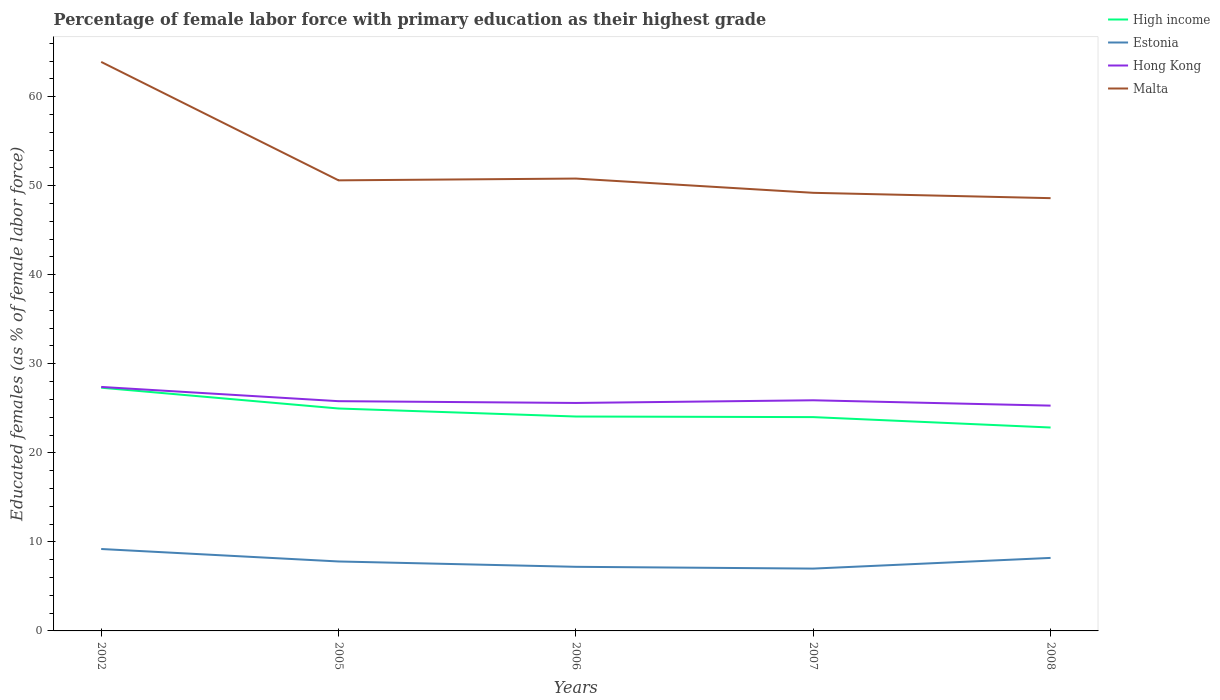Across all years, what is the maximum percentage of female labor force with primary education in Malta?
Your response must be concise. 48.6. What is the total percentage of female labor force with primary education in High income in the graph?
Your response must be concise. 1.24. What is the difference between the highest and the second highest percentage of female labor force with primary education in High income?
Ensure brevity in your answer.  4.47. What is the difference between the highest and the lowest percentage of female labor force with primary education in Malta?
Offer a very short reply. 1. How many lines are there?
Offer a very short reply. 4. How many years are there in the graph?
Your answer should be very brief. 5. What is the difference between two consecutive major ticks on the Y-axis?
Give a very brief answer. 10. Are the values on the major ticks of Y-axis written in scientific E-notation?
Give a very brief answer. No. Does the graph contain grids?
Provide a short and direct response. No. How are the legend labels stacked?
Make the answer very short. Vertical. What is the title of the graph?
Make the answer very short. Percentage of female labor force with primary education as their highest grade. Does "Channel Islands" appear as one of the legend labels in the graph?
Keep it short and to the point. No. What is the label or title of the X-axis?
Your answer should be compact. Years. What is the label or title of the Y-axis?
Your answer should be very brief. Educated females (as % of female labor force). What is the Educated females (as % of female labor force) in High income in 2002?
Offer a very short reply. 27.32. What is the Educated females (as % of female labor force) in Estonia in 2002?
Your response must be concise. 9.2. What is the Educated females (as % of female labor force) of Hong Kong in 2002?
Provide a succinct answer. 27.4. What is the Educated females (as % of female labor force) of Malta in 2002?
Make the answer very short. 63.9. What is the Educated females (as % of female labor force) in High income in 2005?
Give a very brief answer. 24.98. What is the Educated females (as % of female labor force) in Estonia in 2005?
Keep it short and to the point. 7.8. What is the Educated females (as % of female labor force) in Hong Kong in 2005?
Keep it short and to the point. 25.8. What is the Educated females (as % of female labor force) of Malta in 2005?
Offer a terse response. 50.6. What is the Educated females (as % of female labor force) of High income in 2006?
Your answer should be very brief. 24.08. What is the Educated females (as % of female labor force) of Estonia in 2006?
Offer a very short reply. 7.2. What is the Educated females (as % of female labor force) in Hong Kong in 2006?
Make the answer very short. 25.6. What is the Educated females (as % of female labor force) of Malta in 2006?
Offer a very short reply. 50.8. What is the Educated females (as % of female labor force) of High income in 2007?
Your answer should be compact. 24.01. What is the Educated females (as % of female labor force) in Hong Kong in 2007?
Keep it short and to the point. 25.9. What is the Educated females (as % of female labor force) of Malta in 2007?
Your answer should be very brief. 49.2. What is the Educated females (as % of female labor force) in High income in 2008?
Your answer should be very brief. 22.84. What is the Educated females (as % of female labor force) in Estonia in 2008?
Your answer should be compact. 8.2. What is the Educated females (as % of female labor force) of Hong Kong in 2008?
Offer a very short reply. 25.3. What is the Educated females (as % of female labor force) in Malta in 2008?
Your answer should be compact. 48.6. Across all years, what is the maximum Educated females (as % of female labor force) in High income?
Provide a short and direct response. 27.32. Across all years, what is the maximum Educated females (as % of female labor force) in Estonia?
Give a very brief answer. 9.2. Across all years, what is the maximum Educated females (as % of female labor force) in Hong Kong?
Your answer should be very brief. 27.4. Across all years, what is the maximum Educated females (as % of female labor force) in Malta?
Your answer should be compact. 63.9. Across all years, what is the minimum Educated females (as % of female labor force) of High income?
Ensure brevity in your answer.  22.84. Across all years, what is the minimum Educated females (as % of female labor force) in Estonia?
Provide a succinct answer. 7. Across all years, what is the minimum Educated females (as % of female labor force) of Hong Kong?
Keep it short and to the point. 25.3. Across all years, what is the minimum Educated females (as % of female labor force) in Malta?
Your response must be concise. 48.6. What is the total Educated females (as % of female labor force) of High income in the graph?
Keep it short and to the point. 123.22. What is the total Educated females (as % of female labor force) of Estonia in the graph?
Your response must be concise. 39.4. What is the total Educated females (as % of female labor force) in Hong Kong in the graph?
Give a very brief answer. 130. What is the total Educated females (as % of female labor force) of Malta in the graph?
Keep it short and to the point. 263.1. What is the difference between the Educated females (as % of female labor force) in High income in 2002 and that in 2005?
Offer a terse response. 2.34. What is the difference between the Educated females (as % of female labor force) of Estonia in 2002 and that in 2005?
Your response must be concise. 1.4. What is the difference between the Educated females (as % of female labor force) of Hong Kong in 2002 and that in 2005?
Make the answer very short. 1.6. What is the difference between the Educated females (as % of female labor force) of Malta in 2002 and that in 2005?
Keep it short and to the point. 13.3. What is the difference between the Educated females (as % of female labor force) in High income in 2002 and that in 2006?
Provide a short and direct response. 3.24. What is the difference between the Educated females (as % of female labor force) of Estonia in 2002 and that in 2006?
Your answer should be very brief. 2. What is the difference between the Educated females (as % of female labor force) of High income in 2002 and that in 2007?
Your answer should be compact. 3.3. What is the difference between the Educated females (as % of female labor force) of Estonia in 2002 and that in 2007?
Make the answer very short. 2.2. What is the difference between the Educated females (as % of female labor force) of Hong Kong in 2002 and that in 2007?
Your answer should be very brief. 1.5. What is the difference between the Educated females (as % of female labor force) in High income in 2002 and that in 2008?
Your answer should be compact. 4.47. What is the difference between the Educated females (as % of female labor force) of High income in 2005 and that in 2006?
Your answer should be very brief. 0.9. What is the difference between the Educated females (as % of female labor force) in Estonia in 2005 and that in 2006?
Provide a short and direct response. 0.6. What is the difference between the Educated females (as % of female labor force) in High income in 2005 and that in 2007?
Make the answer very short. 0.97. What is the difference between the Educated females (as % of female labor force) in Estonia in 2005 and that in 2007?
Your answer should be compact. 0.8. What is the difference between the Educated females (as % of female labor force) in Hong Kong in 2005 and that in 2007?
Your answer should be very brief. -0.1. What is the difference between the Educated females (as % of female labor force) in High income in 2005 and that in 2008?
Your answer should be very brief. 2.14. What is the difference between the Educated females (as % of female labor force) of Estonia in 2005 and that in 2008?
Give a very brief answer. -0.4. What is the difference between the Educated females (as % of female labor force) in Hong Kong in 2005 and that in 2008?
Give a very brief answer. 0.5. What is the difference between the Educated females (as % of female labor force) of High income in 2006 and that in 2007?
Make the answer very short. 0.07. What is the difference between the Educated females (as % of female labor force) in Estonia in 2006 and that in 2007?
Keep it short and to the point. 0.2. What is the difference between the Educated females (as % of female labor force) in Hong Kong in 2006 and that in 2007?
Keep it short and to the point. -0.3. What is the difference between the Educated females (as % of female labor force) in Malta in 2006 and that in 2007?
Make the answer very short. 1.6. What is the difference between the Educated females (as % of female labor force) of High income in 2006 and that in 2008?
Keep it short and to the point. 1.24. What is the difference between the Educated females (as % of female labor force) in Hong Kong in 2006 and that in 2008?
Ensure brevity in your answer.  0.3. What is the difference between the Educated females (as % of female labor force) in High income in 2007 and that in 2008?
Your response must be concise. 1.17. What is the difference between the Educated females (as % of female labor force) of Malta in 2007 and that in 2008?
Make the answer very short. 0.6. What is the difference between the Educated females (as % of female labor force) in High income in 2002 and the Educated females (as % of female labor force) in Estonia in 2005?
Make the answer very short. 19.52. What is the difference between the Educated females (as % of female labor force) of High income in 2002 and the Educated females (as % of female labor force) of Hong Kong in 2005?
Make the answer very short. 1.51. What is the difference between the Educated females (as % of female labor force) of High income in 2002 and the Educated females (as % of female labor force) of Malta in 2005?
Give a very brief answer. -23.29. What is the difference between the Educated females (as % of female labor force) of Estonia in 2002 and the Educated females (as % of female labor force) of Hong Kong in 2005?
Your response must be concise. -16.6. What is the difference between the Educated females (as % of female labor force) in Estonia in 2002 and the Educated females (as % of female labor force) in Malta in 2005?
Provide a short and direct response. -41.4. What is the difference between the Educated females (as % of female labor force) of Hong Kong in 2002 and the Educated females (as % of female labor force) of Malta in 2005?
Give a very brief answer. -23.2. What is the difference between the Educated females (as % of female labor force) of High income in 2002 and the Educated females (as % of female labor force) of Estonia in 2006?
Provide a succinct answer. 20.11. What is the difference between the Educated females (as % of female labor force) of High income in 2002 and the Educated females (as % of female labor force) of Hong Kong in 2006?
Provide a short and direct response. 1.72. What is the difference between the Educated females (as % of female labor force) in High income in 2002 and the Educated females (as % of female labor force) in Malta in 2006?
Make the answer very short. -23.48. What is the difference between the Educated females (as % of female labor force) in Estonia in 2002 and the Educated females (as % of female labor force) in Hong Kong in 2006?
Provide a succinct answer. -16.4. What is the difference between the Educated females (as % of female labor force) in Estonia in 2002 and the Educated females (as % of female labor force) in Malta in 2006?
Provide a succinct answer. -41.6. What is the difference between the Educated females (as % of female labor force) of Hong Kong in 2002 and the Educated females (as % of female labor force) of Malta in 2006?
Provide a short and direct response. -23.4. What is the difference between the Educated females (as % of female labor force) in High income in 2002 and the Educated females (as % of female labor force) in Estonia in 2007?
Provide a succinct answer. 20.32. What is the difference between the Educated females (as % of female labor force) in High income in 2002 and the Educated females (as % of female labor force) in Hong Kong in 2007?
Your answer should be very brief. 1.42. What is the difference between the Educated females (as % of female labor force) in High income in 2002 and the Educated females (as % of female labor force) in Malta in 2007?
Your answer should be very brief. -21.89. What is the difference between the Educated females (as % of female labor force) in Estonia in 2002 and the Educated females (as % of female labor force) in Hong Kong in 2007?
Provide a succinct answer. -16.7. What is the difference between the Educated females (as % of female labor force) in Estonia in 2002 and the Educated females (as % of female labor force) in Malta in 2007?
Ensure brevity in your answer.  -40. What is the difference between the Educated females (as % of female labor force) in Hong Kong in 2002 and the Educated females (as % of female labor force) in Malta in 2007?
Ensure brevity in your answer.  -21.8. What is the difference between the Educated females (as % of female labor force) in High income in 2002 and the Educated females (as % of female labor force) in Estonia in 2008?
Your answer should be compact. 19.11. What is the difference between the Educated females (as % of female labor force) of High income in 2002 and the Educated females (as % of female labor force) of Hong Kong in 2008?
Keep it short and to the point. 2.02. What is the difference between the Educated females (as % of female labor force) in High income in 2002 and the Educated females (as % of female labor force) in Malta in 2008?
Offer a terse response. -21.29. What is the difference between the Educated females (as % of female labor force) in Estonia in 2002 and the Educated females (as % of female labor force) in Hong Kong in 2008?
Provide a short and direct response. -16.1. What is the difference between the Educated females (as % of female labor force) of Estonia in 2002 and the Educated females (as % of female labor force) of Malta in 2008?
Offer a very short reply. -39.4. What is the difference between the Educated females (as % of female labor force) in Hong Kong in 2002 and the Educated females (as % of female labor force) in Malta in 2008?
Your answer should be very brief. -21.2. What is the difference between the Educated females (as % of female labor force) of High income in 2005 and the Educated females (as % of female labor force) of Estonia in 2006?
Give a very brief answer. 17.78. What is the difference between the Educated females (as % of female labor force) of High income in 2005 and the Educated females (as % of female labor force) of Hong Kong in 2006?
Give a very brief answer. -0.62. What is the difference between the Educated females (as % of female labor force) in High income in 2005 and the Educated females (as % of female labor force) in Malta in 2006?
Keep it short and to the point. -25.82. What is the difference between the Educated females (as % of female labor force) in Estonia in 2005 and the Educated females (as % of female labor force) in Hong Kong in 2006?
Your answer should be compact. -17.8. What is the difference between the Educated females (as % of female labor force) of Estonia in 2005 and the Educated females (as % of female labor force) of Malta in 2006?
Your response must be concise. -43. What is the difference between the Educated females (as % of female labor force) of High income in 2005 and the Educated females (as % of female labor force) of Estonia in 2007?
Keep it short and to the point. 17.98. What is the difference between the Educated females (as % of female labor force) of High income in 2005 and the Educated females (as % of female labor force) of Hong Kong in 2007?
Your response must be concise. -0.92. What is the difference between the Educated females (as % of female labor force) of High income in 2005 and the Educated females (as % of female labor force) of Malta in 2007?
Offer a very short reply. -24.22. What is the difference between the Educated females (as % of female labor force) of Estonia in 2005 and the Educated females (as % of female labor force) of Hong Kong in 2007?
Make the answer very short. -18.1. What is the difference between the Educated females (as % of female labor force) in Estonia in 2005 and the Educated females (as % of female labor force) in Malta in 2007?
Ensure brevity in your answer.  -41.4. What is the difference between the Educated females (as % of female labor force) of Hong Kong in 2005 and the Educated females (as % of female labor force) of Malta in 2007?
Provide a short and direct response. -23.4. What is the difference between the Educated females (as % of female labor force) of High income in 2005 and the Educated females (as % of female labor force) of Estonia in 2008?
Make the answer very short. 16.78. What is the difference between the Educated females (as % of female labor force) of High income in 2005 and the Educated females (as % of female labor force) of Hong Kong in 2008?
Offer a very short reply. -0.32. What is the difference between the Educated females (as % of female labor force) of High income in 2005 and the Educated females (as % of female labor force) of Malta in 2008?
Your response must be concise. -23.62. What is the difference between the Educated females (as % of female labor force) of Estonia in 2005 and the Educated females (as % of female labor force) of Hong Kong in 2008?
Offer a terse response. -17.5. What is the difference between the Educated females (as % of female labor force) of Estonia in 2005 and the Educated females (as % of female labor force) of Malta in 2008?
Keep it short and to the point. -40.8. What is the difference between the Educated females (as % of female labor force) of Hong Kong in 2005 and the Educated females (as % of female labor force) of Malta in 2008?
Keep it short and to the point. -22.8. What is the difference between the Educated females (as % of female labor force) in High income in 2006 and the Educated females (as % of female labor force) in Estonia in 2007?
Give a very brief answer. 17.08. What is the difference between the Educated females (as % of female labor force) in High income in 2006 and the Educated females (as % of female labor force) in Hong Kong in 2007?
Offer a very short reply. -1.82. What is the difference between the Educated females (as % of female labor force) in High income in 2006 and the Educated females (as % of female labor force) in Malta in 2007?
Ensure brevity in your answer.  -25.12. What is the difference between the Educated females (as % of female labor force) in Estonia in 2006 and the Educated females (as % of female labor force) in Hong Kong in 2007?
Provide a succinct answer. -18.7. What is the difference between the Educated females (as % of female labor force) in Estonia in 2006 and the Educated females (as % of female labor force) in Malta in 2007?
Provide a succinct answer. -42. What is the difference between the Educated females (as % of female labor force) in Hong Kong in 2006 and the Educated females (as % of female labor force) in Malta in 2007?
Your answer should be compact. -23.6. What is the difference between the Educated females (as % of female labor force) of High income in 2006 and the Educated females (as % of female labor force) of Estonia in 2008?
Ensure brevity in your answer.  15.88. What is the difference between the Educated females (as % of female labor force) of High income in 2006 and the Educated females (as % of female labor force) of Hong Kong in 2008?
Provide a succinct answer. -1.22. What is the difference between the Educated females (as % of female labor force) in High income in 2006 and the Educated females (as % of female labor force) in Malta in 2008?
Ensure brevity in your answer.  -24.52. What is the difference between the Educated females (as % of female labor force) of Estonia in 2006 and the Educated females (as % of female labor force) of Hong Kong in 2008?
Give a very brief answer. -18.1. What is the difference between the Educated females (as % of female labor force) of Estonia in 2006 and the Educated females (as % of female labor force) of Malta in 2008?
Make the answer very short. -41.4. What is the difference between the Educated females (as % of female labor force) in High income in 2007 and the Educated females (as % of female labor force) in Estonia in 2008?
Keep it short and to the point. 15.81. What is the difference between the Educated females (as % of female labor force) of High income in 2007 and the Educated females (as % of female labor force) of Hong Kong in 2008?
Make the answer very short. -1.29. What is the difference between the Educated females (as % of female labor force) of High income in 2007 and the Educated females (as % of female labor force) of Malta in 2008?
Offer a terse response. -24.59. What is the difference between the Educated females (as % of female labor force) of Estonia in 2007 and the Educated females (as % of female labor force) of Hong Kong in 2008?
Offer a terse response. -18.3. What is the difference between the Educated females (as % of female labor force) of Estonia in 2007 and the Educated females (as % of female labor force) of Malta in 2008?
Your answer should be very brief. -41.6. What is the difference between the Educated females (as % of female labor force) in Hong Kong in 2007 and the Educated females (as % of female labor force) in Malta in 2008?
Provide a short and direct response. -22.7. What is the average Educated females (as % of female labor force) of High income per year?
Offer a terse response. 24.64. What is the average Educated females (as % of female labor force) in Estonia per year?
Your response must be concise. 7.88. What is the average Educated females (as % of female labor force) in Malta per year?
Make the answer very short. 52.62. In the year 2002, what is the difference between the Educated females (as % of female labor force) in High income and Educated females (as % of female labor force) in Estonia?
Ensure brevity in your answer.  18.11. In the year 2002, what is the difference between the Educated females (as % of female labor force) of High income and Educated females (as % of female labor force) of Hong Kong?
Your response must be concise. -0.09. In the year 2002, what is the difference between the Educated females (as % of female labor force) in High income and Educated females (as % of female labor force) in Malta?
Keep it short and to the point. -36.59. In the year 2002, what is the difference between the Educated females (as % of female labor force) of Estonia and Educated females (as % of female labor force) of Hong Kong?
Ensure brevity in your answer.  -18.2. In the year 2002, what is the difference between the Educated females (as % of female labor force) in Estonia and Educated females (as % of female labor force) in Malta?
Provide a succinct answer. -54.7. In the year 2002, what is the difference between the Educated females (as % of female labor force) of Hong Kong and Educated females (as % of female labor force) of Malta?
Ensure brevity in your answer.  -36.5. In the year 2005, what is the difference between the Educated females (as % of female labor force) in High income and Educated females (as % of female labor force) in Estonia?
Make the answer very short. 17.18. In the year 2005, what is the difference between the Educated females (as % of female labor force) of High income and Educated females (as % of female labor force) of Hong Kong?
Your response must be concise. -0.82. In the year 2005, what is the difference between the Educated females (as % of female labor force) in High income and Educated females (as % of female labor force) in Malta?
Your response must be concise. -25.62. In the year 2005, what is the difference between the Educated females (as % of female labor force) of Estonia and Educated females (as % of female labor force) of Malta?
Your answer should be very brief. -42.8. In the year 2005, what is the difference between the Educated females (as % of female labor force) in Hong Kong and Educated females (as % of female labor force) in Malta?
Provide a short and direct response. -24.8. In the year 2006, what is the difference between the Educated females (as % of female labor force) of High income and Educated females (as % of female labor force) of Estonia?
Give a very brief answer. 16.88. In the year 2006, what is the difference between the Educated females (as % of female labor force) in High income and Educated females (as % of female labor force) in Hong Kong?
Your response must be concise. -1.52. In the year 2006, what is the difference between the Educated females (as % of female labor force) of High income and Educated females (as % of female labor force) of Malta?
Keep it short and to the point. -26.72. In the year 2006, what is the difference between the Educated females (as % of female labor force) in Estonia and Educated females (as % of female labor force) in Hong Kong?
Offer a very short reply. -18.4. In the year 2006, what is the difference between the Educated females (as % of female labor force) of Estonia and Educated females (as % of female labor force) of Malta?
Give a very brief answer. -43.6. In the year 2006, what is the difference between the Educated females (as % of female labor force) in Hong Kong and Educated females (as % of female labor force) in Malta?
Provide a short and direct response. -25.2. In the year 2007, what is the difference between the Educated females (as % of female labor force) in High income and Educated females (as % of female labor force) in Estonia?
Provide a succinct answer. 17.01. In the year 2007, what is the difference between the Educated females (as % of female labor force) of High income and Educated females (as % of female labor force) of Hong Kong?
Provide a short and direct response. -1.89. In the year 2007, what is the difference between the Educated females (as % of female labor force) in High income and Educated females (as % of female labor force) in Malta?
Your answer should be very brief. -25.19. In the year 2007, what is the difference between the Educated females (as % of female labor force) in Estonia and Educated females (as % of female labor force) in Hong Kong?
Offer a terse response. -18.9. In the year 2007, what is the difference between the Educated females (as % of female labor force) in Estonia and Educated females (as % of female labor force) in Malta?
Your answer should be compact. -42.2. In the year 2007, what is the difference between the Educated females (as % of female labor force) of Hong Kong and Educated females (as % of female labor force) of Malta?
Your answer should be very brief. -23.3. In the year 2008, what is the difference between the Educated females (as % of female labor force) of High income and Educated females (as % of female labor force) of Estonia?
Offer a terse response. 14.64. In the year 2008, what is the difference between the Educated females (as % of female labor force) of High income and Educated females (as % of female labor force) of Hong Kong?
Give a very brief answer. -2.46. In the year 2008, what is the difference between the Educated females (as % of female labor force) in High income and Educated females (as % of female labor force) in Malta?
Offer a very short reply. -25.76. In the year 2008, what is the difference between the Educated females (as % of female labor force) of Estonia and Educated females (as % of female labor force) of Hong Kong?
Offer a terse response. -17.1. In the year 2008, what is the difference between the Educated females (as % of female labor force) in Estonia and Educated females (as % of female labor force) in Malta?
Your response must be concise. -40.4. In the year 2008, what is the difference between the Educated females (as % of female labor force) in Hong Kong and Educated females (as % of female labor force) in Malta?
Give a very brief answer. -23.3. What is the ratio of the Educated females (as % of female labor force) in High income in 2002 to that in 2005?
Make the answer very short. 1.09. What is the ratio of the Educated females (as % of female labor force) in Estonia in 2002 to that in 2005?
Make the answer very short. 1.18. What is the ratio of the Educated females (as % of female labor force) in Hong Kong in 2002 to that in 2005?
Provide a short and direct response. 1.06. What is the ratio of the Educated females (as % of female labor force) of Malta in 2002 to that in 2005?
Provide a succinct answer. 1.26. What is the ratio of the Educated females (as % of female labor force) of High income in 2002 to that in 2006?
Your response must be concise. 1.13. What is the ratio of the Educated females (as % of female labor force) in Estonia in 2002 to that in 2006?
Provide a succinct answer. 1.28. What is the ratio of the Educated females (as % of female labor force) of Hong Kong in 2002 to that in 2006?
Offer a terse response. 1.07. What is the ratio of the Educated females (as % of female labor force) of Malta in 2002 to that in 2006?
Ensure brevity in your answer.  1.26. What is the ratio of the Educated females (as % of female labor force) of High income in 2002 to that in 2007?
Make the answer very short. 1.14. What is the ratio of the Educated females (as % of female labor force) in Estonia in 2002 to that in 2007?
Give a very brief answer. 1.31. What is the ratio of the Educated females (as % of female labor force) of Hong Kong in 2002 to that in 2007?
Offer a terse response. 1.06. What is the ratio of the Educated females (as % of female labor force) in Malta in 2002 to that in 2007?
Offer a very short reply. 1.3. What is the ratio of the Educated females (as % of female labor force) of High income in 2002 to that in 2008?
Your response must be concise. 1.2. What is the ratio of the Educated females (as % of female labor force) in Estonia in 2002 to that in 2008?
Give a very brief answer. 1.12. What is the ratio of the Educated females (as % of female labor force) in Hong Kong in 2002 to that in 2008?
Keep it short and to the point. 1.08. What is the ratio of the Educated females (as % of female labor force) in Malta in 2002 to that in 2008?
Make the answer very short. 1.31. What is the ratio of the Educated females (as % of female labor force) in High income in 2005 to that in 2006?
Provide a succinct answer. 1.04. What is the ratio of the Educated females (as % of female labor force) of High income in 2005 to that in 2007?
Your response must be concise. 1.04. What is the ratio of the Educated females (as % of female labor force) of Estonia in 2005 to that in 2007?
Provide a short and direct response. 1.11. What is the ratio of the Educated females (as % of female labor force) in Malta in 2005 to that in 2007?
Ensure brevity in your answer.  1.03. What is the ratio of the Educated females (as % of female labor force) in High income in 2005 to that in 2008?
Offer a terse response. 1.09. What is the ratio of the Educated females (as % of female labor force) of Estonia in 2005 to that in 2008?
Ensure brevity in your answer.  0.95. What is the ratio of the Educated females (as % of female labor force) in Hong Kong in 2005 to that in 2008?
Make the answer very short. 1.02. What is the ratio of the Educated females (as % of female labor force) of Malta in 2005 to that in 2008?
Make the answer very short. 1.04. What is the ratio of the Educated females (as % of female labor force) of Estonia in 2006 to that in 2007?
Your answer should be very brief. 1.03. What is the ratio of the Educated females (as % of female labor force) in Hong Kong in 2006 to that in 2007?
Ensure brevity in your answer.  0.99. What is the ratio of the Educated females (as % of female labor force) of Malta in 2006 to that in 2007?
Make the answer very short. 1.03. What is the ratio of the Educated females (as % of female labor force) of High income in 2006 to that in 2008?
Give a very brief answer. 1.05. What is the ratio of the Educated females (as % of female labor force) in Estonia in 2006 to that in 2008?
Provide a short and direct response. 0.88. What is the ratio of the Educated females (as % of female labor force) in Hong Kong in 2006 to that in 2008?
Make the answer very short. 1.01. What is the ratio of the Educated females (as % of female labor force) in Malta in 2006 to that in 2008?
Give a very brief answer. 1.05. What is the ratio of the Educated females (as % of female labor force) of High income in 2007 to that in 2008?
Your response must be concise. 1.05. What is the ratio of the Educated females (as % of female labor force) of Estonia in 2007 to that in 2008?
Offer a terse response. 0.85. What is the ratio of the Educated females (as % of female labor force) in Hong Kong in 2007 to that in 2008?
Ensure brevity in your answer.  1.02. What is the ratio of the Educated females (as % of female labor force) of Malta in 2007 to that in 2008?
Ensure brevity in your answer.  1.01. What is the difference between the highest and the second highest Educated females (as % of female labor force) in High income?
Provide a short and direct response. 2.34. What is the difference between the highest and the second highest Educated females (as % of female labor force) in Estonia?
Give a very brief answer. 1. What is the difference between the highest and the second highest Educated females (as % of female labor force) of Hong Kong?
Make the answer very short. 1.5. What is the difference between the highest and the lowest Educated females (as % of female labor force) in High income?
Ensure brevity in your answer.  4.47. What is the difference between the highest and the lowest Educated females (as % of female labor force) in Hong Kong?
Offer a terse response. 2.1. What is the difference between the highest and the lowest Educated females (as % of female labor force) in Malta?
Offer a terse response. 15.3. 